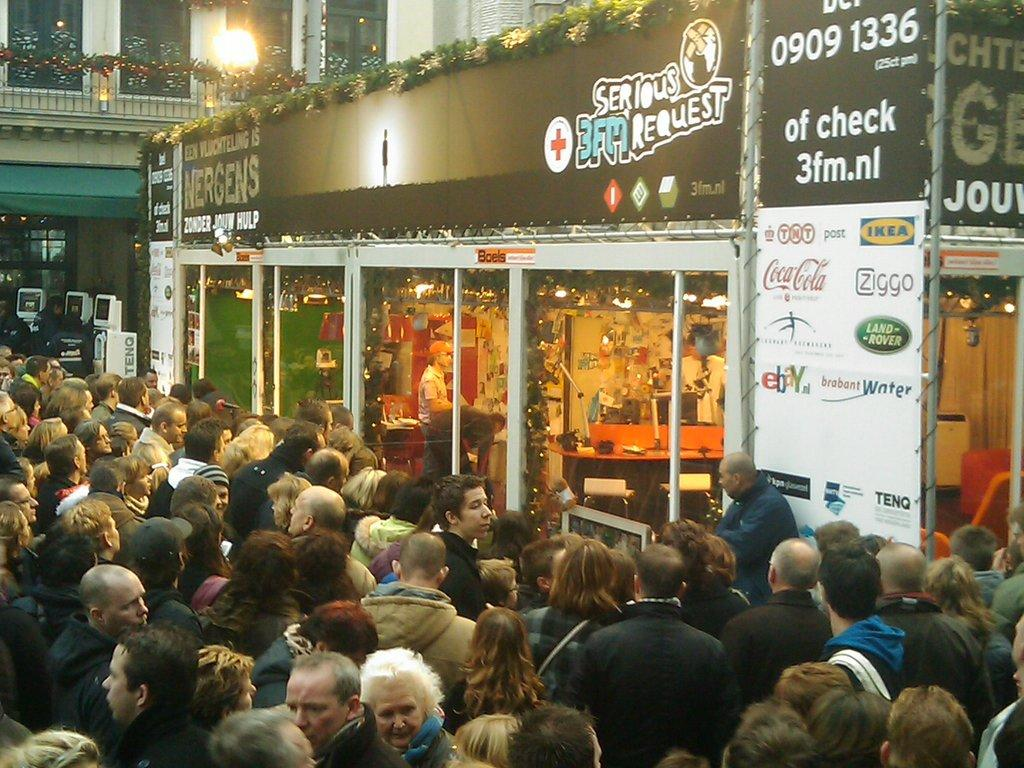What are the people in the image doing? The persons are standing in front of a store. What can be seen on the store in the image? The store has something written on it. What is visible in the background of the image? There is a light and a building in the background. What grade of wood is used to frame the light in the image? There is no mention of a frame or wood in the image, and the light is not described in detail. 